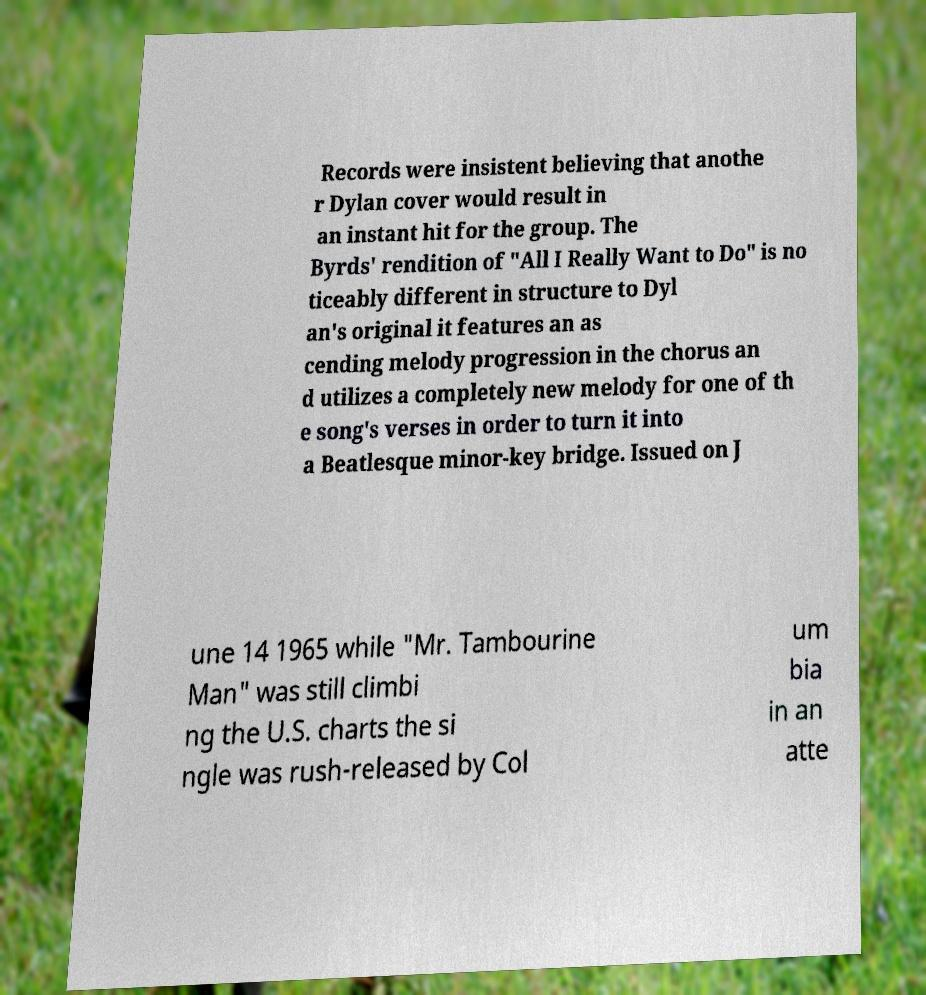There's text embedded in this image that I need extracted. Can you transcribe it verbatim? Records were insistent believing that anothe r Dylan cover would result in an instant hit for the group. The Byrds' rendition of "All I Really Want to Do" is no ticeably different in structure to Dyl an's original it features an as cending melody progression in the chorus an d utilizes a completely new melody for one of th e song's verses in order to turn it into a Beatlesque minor-key bridge. Issued on J une 14 1965 while "Mr. Tambourine Man" was still climbi ng the U.S. charts the si ngle was rush-released by Col um bia in an atte 